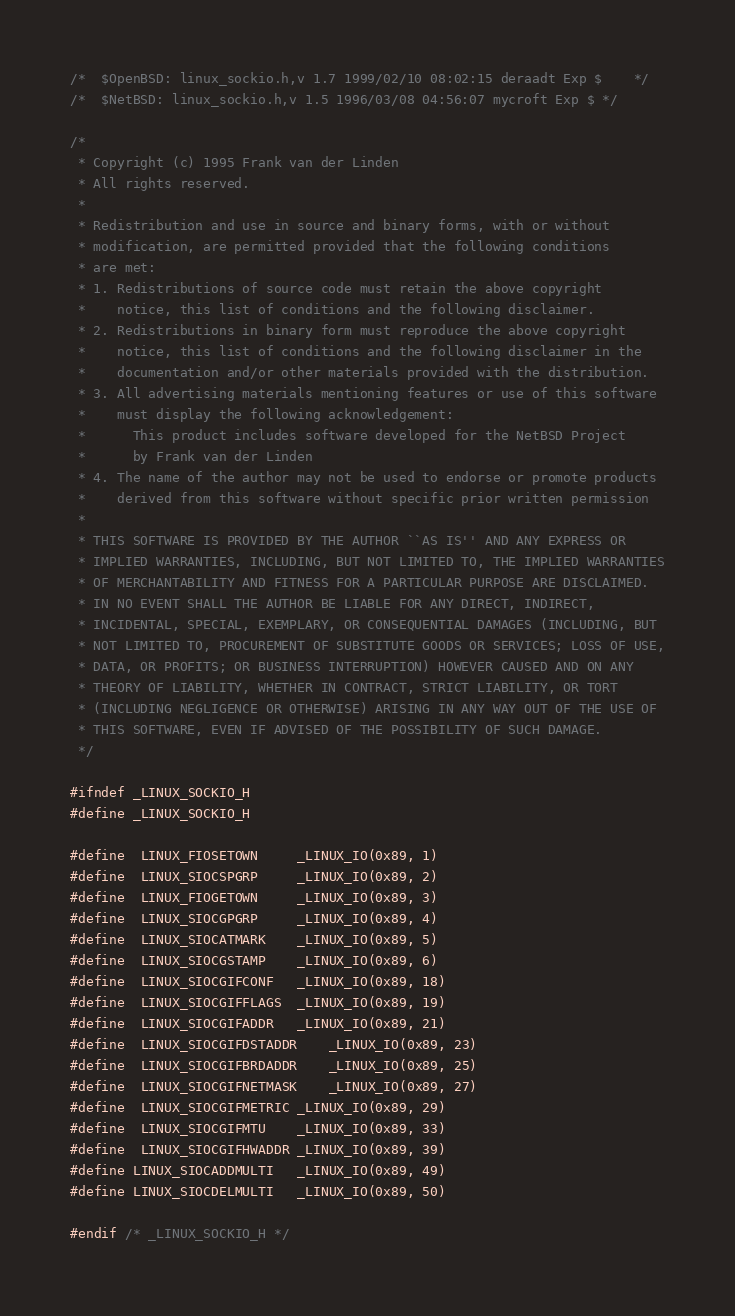Convert code to text. <code><loc_0><loc_0><loc_500><loc_500><_C_>/*	$OpenBSD: linux_sockio.h,v 1.7 1999/02/10 08:02:15 deraadt Exp $	*/
/*	$NetBSD: linux_sockio.h,v 1.5 1996/03/08 04:56:07 mycroft Exp $	*/

/*
 * Copyright (c) 1995 Frank van der Linden
 * All rights reserved.
 *
 * Redistribution and use in source and binary forms, with or without
 * modification, are permitted provided that the following conditions
 * are met:
 * 1. Redistributions of source code must retain the above copyright
 *    notice, this list of conditions and the following disclaimer.
 * 2. Redistributions in binary form must reproduce the above copyright
 *    notice, this list of conditions and the following disclaimer in the
 *    documentation and/or other materials provided with the distribution.
 * 3. All advertising materials mentioning features or use of this software
 *    must display the following acknowledgement:
 *      This product includes software developed for the NetBSD Project
 *      by Frank van der Linden
 * 4. The name of the author may not be used to endorse or promote products
 *    derived from this software without specific prior written permission
 *
 * THIS SOFTWARE IS PROVIDED BY THE AUTHOR ``AS IS'' AND ANY EXPRESS OR
 * IMPLIED WARRANTIES, INCLUDING, BUT NOT LIMITED TO, THE IMPLIED WARRANTIES
 * OF MERCHANTABILITY AND FITNESS FOR A PARTICULAR PURPOSE ARE DISCLAIMED.
 * IN NO EVENT SHALL THE AUTHOR BE LIABLE FOR ANY DIRECT, INDIRECT,
 * INCIDENTAL, SPECIAL, EXEMPLARY, OR CONSEQUENTIAL DAMAGES (INCLUDING, BUT
 * NOT LIMITED TO, PROCUREMENT OF SUBSTITUTE GOODS OR SERVICES; LOSS OF USE,
 * DATA, OR PROFITS; OR BUSINESS INTERRUPTION) HOWEVER CAUSED AND ON ANY
 * THEORY OF LIABILITY, WHETHER IN CONTRACT, STRICT LIABILITY, OR TORT
 * (INCLUDING NEGLIGENCE OR OTHERWISE) ARISING IN ANY WAY OUT OF THE USE OF
 * THIS SOFTWARE, EVEN IF ADVISED OF THE POSSIBILITY OF SUCH DAMAGE.
 */

#ifndef _LINUX_SOCKIO_H
#define _LINUX_SOCKIO_H

#define	LINUX_FIOSETOWN		_LINUX_IO(0x89, 1)
#define	LINUX_SIOCSPGRP		_LINUX_IO(0x89, 2)
#define	LINUX_FIOGETOWN		_LINUX_IO(0x89, 3)
#define	LINUX_SIOCGPGRP		_LINUX_IO(0x89, 4)
#define	LINUX_SIOCATMARK	_LINUX_IO(0x89, 5)
#define	LINUX_SIOCGSTAMP	_LINUX_IO(0x89, 6)
#define	LINUX_SIOCGIFCONF	_LINUX_IO(0x89, 18)
#define	LINUX_SIOCGIFFLAGS	_LINUX_IO(0x89, 19)
#define	LINUX_SIOCGIFADDR	_LINUX_IO(0x89, 21)
#define	LINUX_SIOCGIFDSTADDR	_LINUX_IO(0x89, 23)
#define	LINUX_SIOCGIFBRDADDR	_LINUX_IO(0x89, 25)
#define	LINUX_SIOCGIFNETMASK	_LINUX_IO(0x89, 27)
#define	LINUX_SIOCGIFMETRIC	_LINUX_IO(0x89, 29)
#define	LINUX_SIOCGIFMTU	_LINUX_IO(0x89, 33)
#define	LINUX_SIOCGIFHWADDR	_LINUX_IO(0x89, 39)
#define LINUX_SIOCADDMULTI	_LINUX_IO(0x89, 49)
#define LINUX_SIOCDELMULTI	_LINUX_IO(0x89, 50)

#endif /* _LINUX_SOCKIO_H */
</code> 